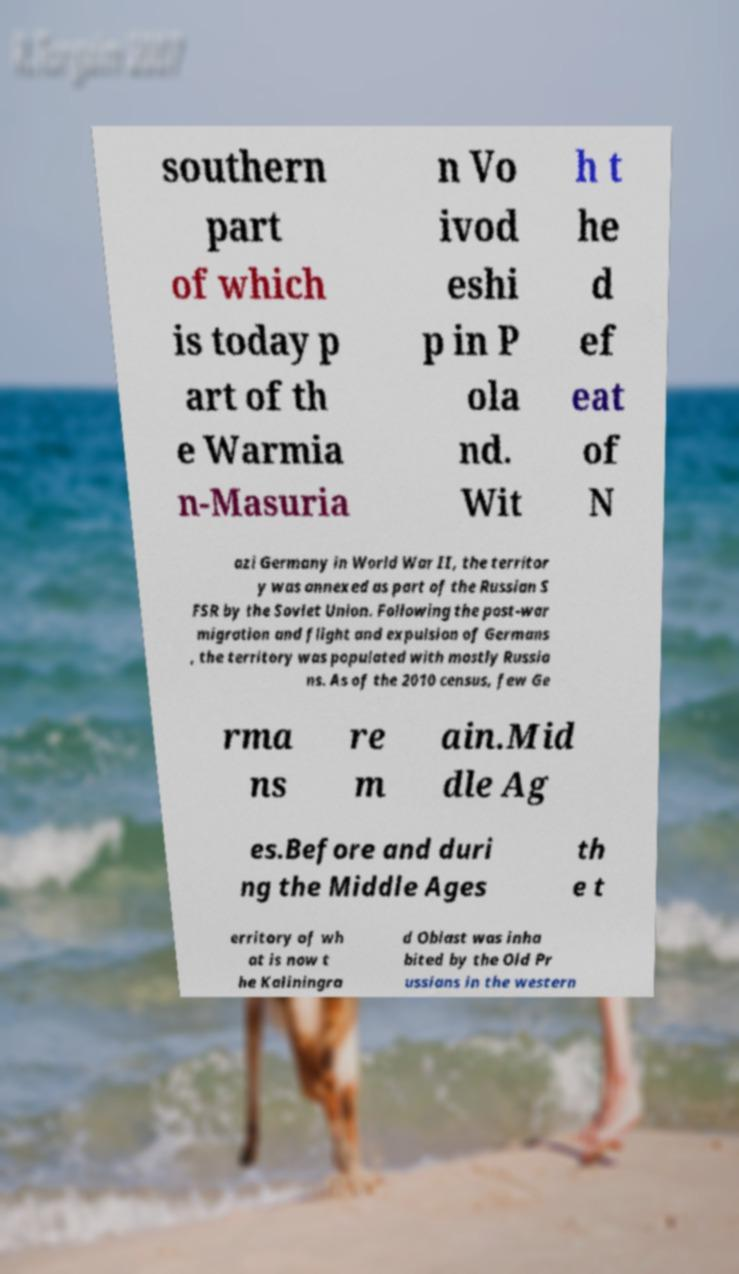I need the written content from this picture converted into text. Can you do that? southern part of which is today p art of th e Warmia n-Masuria n Vo ivod eshi p in P ola nd. Wit h t he d ef eat of N azi Germany in World War II, the territor y was annexed as part of the Russian S FSR by the Soviet Union. Following the post-war migration and flight and expulsion of Germans , the territory was populated with mostly Russia ns. As of the 2010 census, few Ge rma ns re m ain.Mid dle Ag es.Before and duri ng the Middle Ages th e t erritory of wh at is now t he Kaliningra d Oblast was inha bited by the Old Pr ussians in the western 